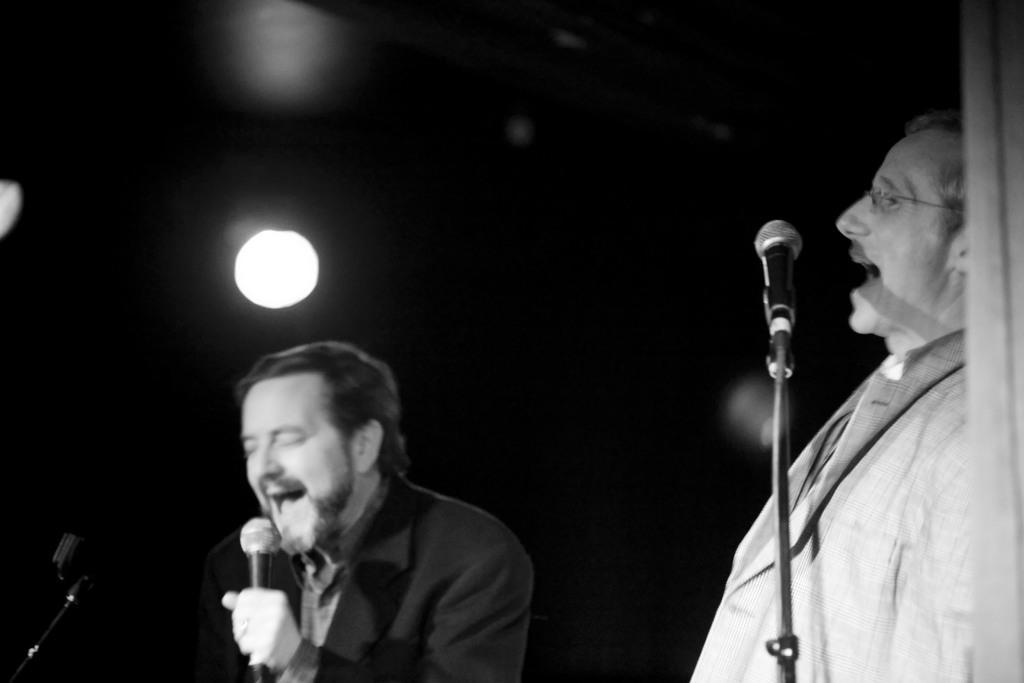Please provide a concise description of this image. In this picture we can see two men where here person wore blazer, spectacle and they both are singing on mics and in background we can see light and it is dark. 